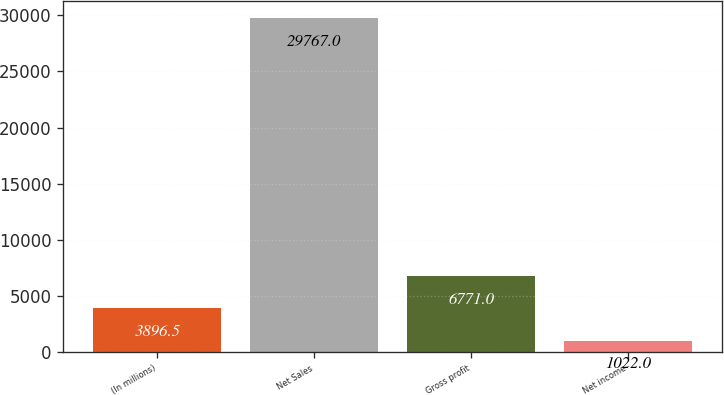Convert chart to OTSL. <chart><loc_0><loc_0><loc_500><loc_500><bar_chart><fcel>(In millions)<fcel>Net Sales<fcel>Gross profit<fcel>Net income<nl><fcel>3896.5<fcel>29767<fcel>6771<fcel>1022<nl></chart> 